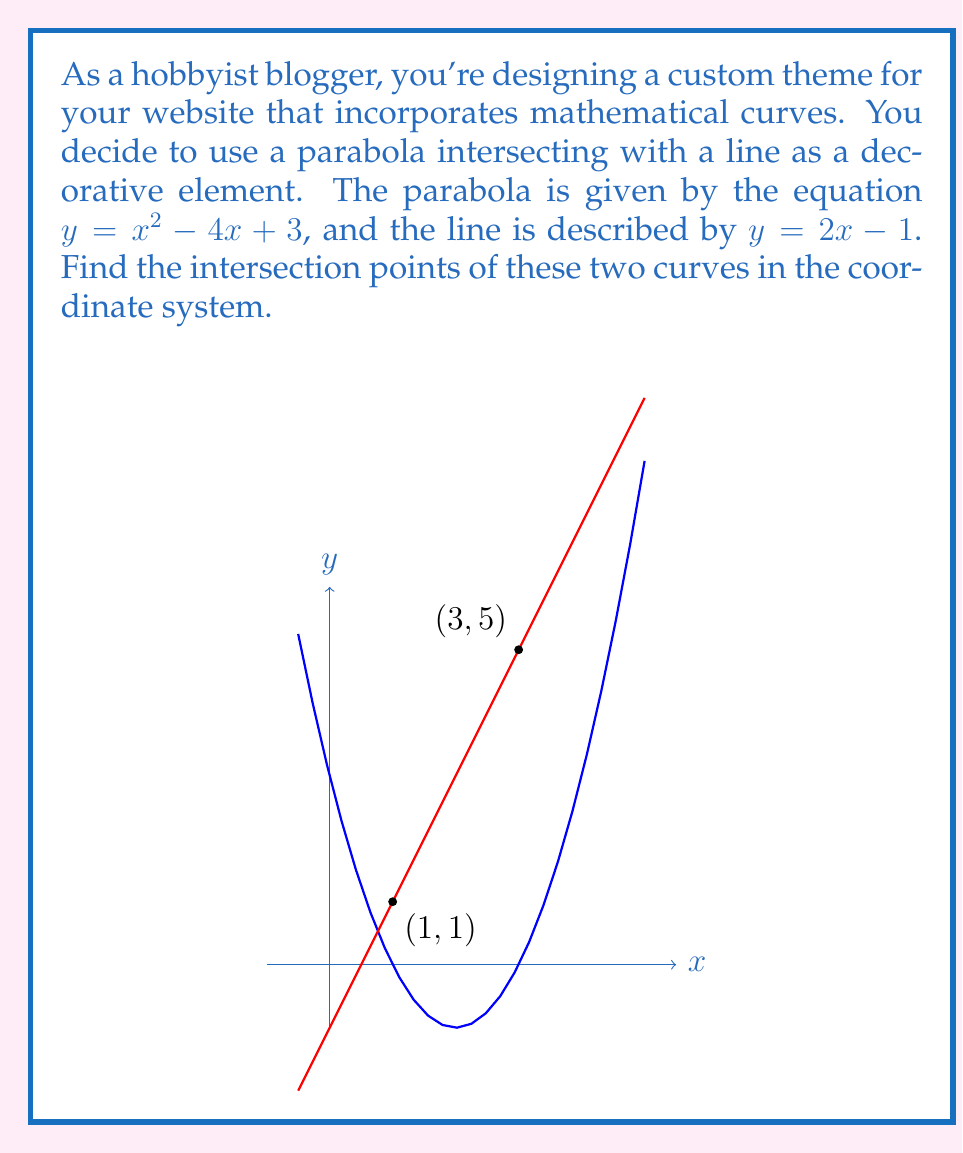Give your solution to this math problem. To find the intersection points, we need to solve the system of equations:

$$\begin{cases}
y = x^2 - 4x + 3 \\
y = 2x - 1
\end{cases}$$

Step 1: Set the equations equal to each other.
$x^2 - 4x + 3 = 2x - 1$

Step 2: Rearrange the equation to standard form.
$x^2 - 6x + 4 = 0$

Step 3: Solve the quadratic equation using the quadratic formula.
$x = \frac{-b \pm \sqrt{b^2 - 4ac}}{2a}$

Where $a=1$, $b=-6$, and $c=4$

$x = \frac{6 \pm \sqrt{36 - 16}}{2} = \frac{6 \pm \sqrt{20}}{2} = \frac{6 \pm 2\sqrt{5}}{2}$

Step 4: Simplify the solutions.
$x_1 = \frac{6 + 2\sqrt{5}}{2} = 3 + \sqrt{5}$
$x_2 = \frac{6 - 2\sqrt{5}}{2} = 3 - \sqrt{5}$

Step 5: Find the corresponding y-values by substituting the x-values into either of the original equations. Let's use $y = 2x - 1$.

For $x_1$: $y_1 = 2(3 + \sqrt{5}) - 1 = 5 + 2\sqrt{5}$
For $x_2$: $y_2 = 2(3 - \sqrt{5}) - 1 = 5 - 2\sqrt{5}$

Therefore, the intersection points are $(3 + \sqrt{5}, 5 + 2\sqrt{5})$ and $(3 - \sqrt{5}, 5 - 2\sqrt{5})$.
Answer: $(3 + \sqrt{5}, 5 + 2\sqrt{5})$ and $(3 - \sqrt{5}, 5 - 2\sqrt{5})$ 